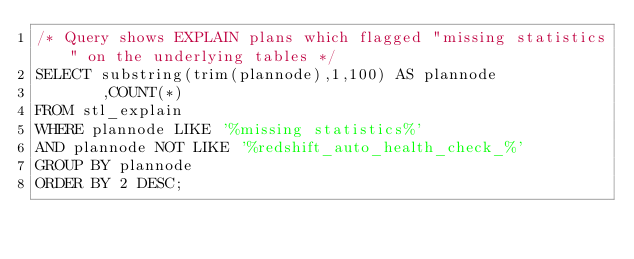Convert code to text. <code><loc_0><loc_0><loc_500><loc_500><_SQL_>/* Query shows EXPLAIN plans which flagged "missing statistics" on the underlying tables */
SELECT substring(trim(plannode),1,100) AS plannode
       ,COUNT(*)
FROM stl_explain
WHERE plannode LIKE '%missing statistics%'
AND plannode NOT LIKE '%redshift_auto_health_check_%'
GROUP BY plannode
ORDER BY 2 DESC;
</code> 